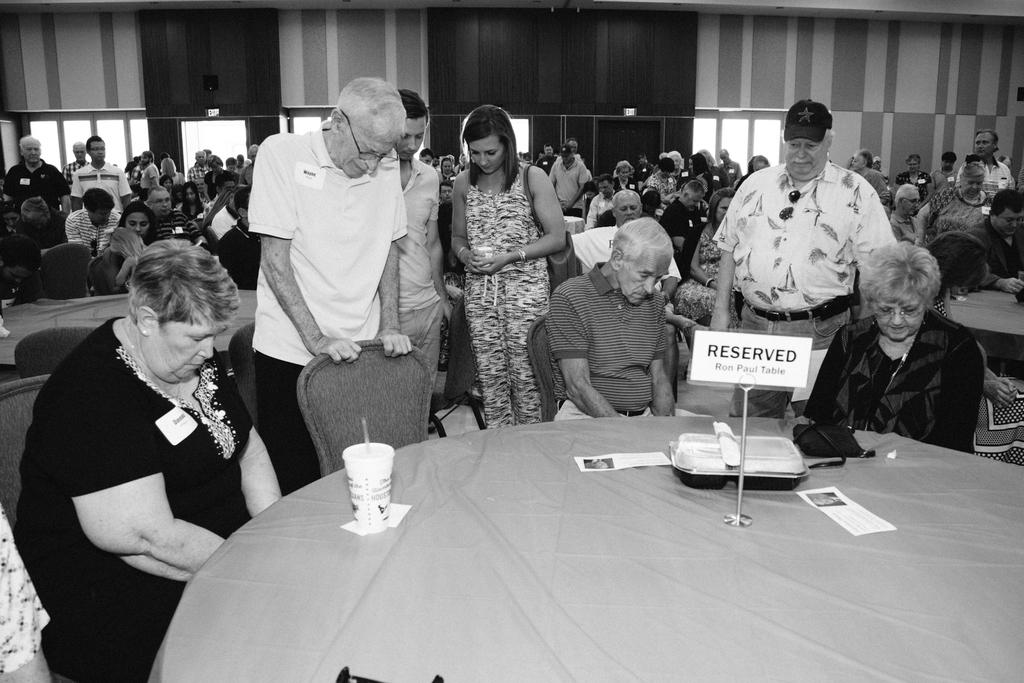What is the general setting of the image? There is a crowd in the room. How are the people in the crowd positioned? Some people in the crowd are standing, while others are sitting on chairs. What might the people in the crowd be focused on? The people in the crowd are thinking about something. What piece of furniture is present in the room? There is a table in the room. What is on the table? The table has a reserve board on it. What type of farmer is present in the image? There is no farmer present in the image; it features a crowd in a room. What dish is the cook preparing in the image? There is no cook or dish preparation present in the image. 